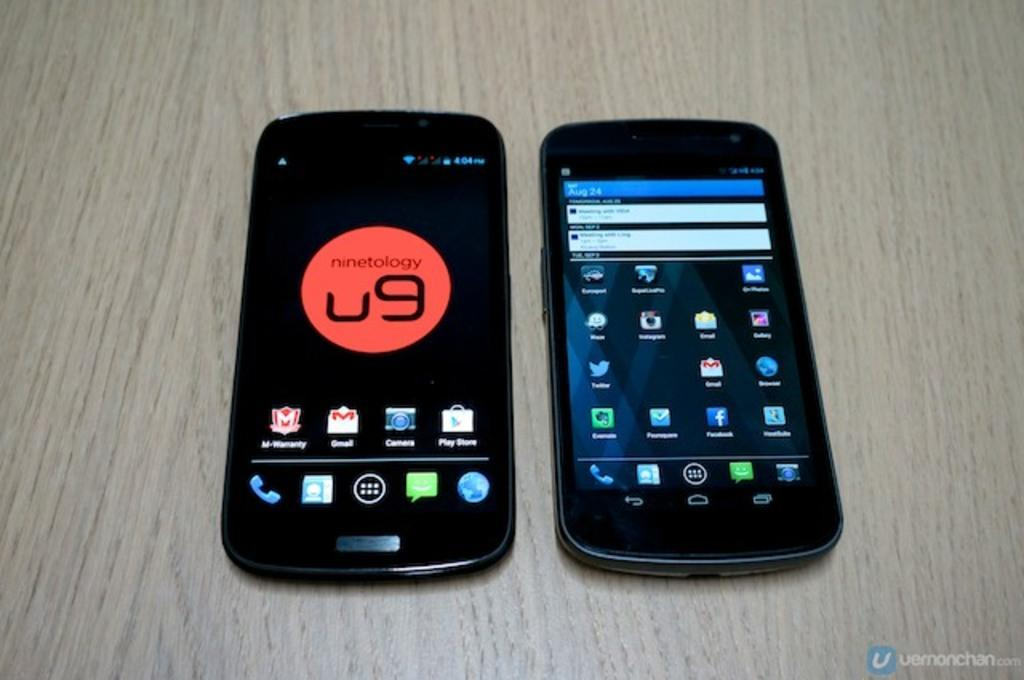How many mobiles are on the table in the image? There are two mobiles on the table in the image. What is the color of the table in the image? The table is brown in color. What type of wing is visible on the edge of the table in the image? There is no wing visible on the edge of the table in the image. What kind of marble is present on the table in the image? There is no marble present on the table in the image. 